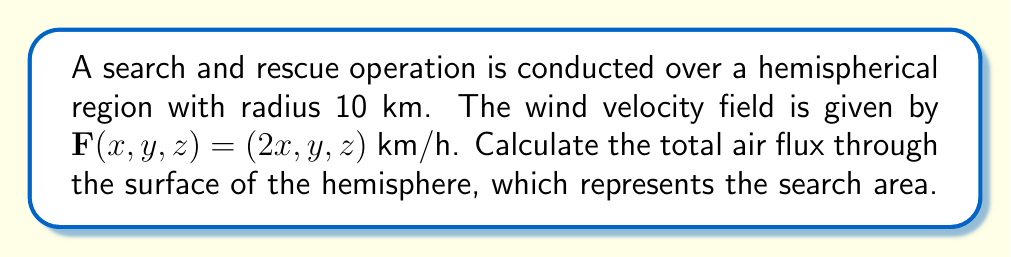Help me with this question. To solve this problem, we'll use the divergence theorem, which relates the flux of a vector field through a closed surface to the divergence of the field within the volume enclosed by the surface.

Step 1: Set up the divergence theorem
$$\iint_S \mathbf{F} \cdot \mathbf{n} \, dS = \iiint_V \nabla \cdot \mathbf{F} \, dV$$

Step 2: Calculate the divergence of $\mathbf{F}$
$$\nabla \cdot \mathbf{F} = \frac{\partial}{\partial x}(2x) + \frac{\partial}{\partial y}(y) + \frac{\partial}{\partial z}(z) = 2 + 1 + 1 = 4$$

Step 3: Set up the volume integral
The volume of a hemisphere is $\frac{2}{3}\pi r^3$, so our integral becomes:
$$\iiint_V \nabla \cdot \mathbf{F} \, dV = 4 \cdot \frac{2}{3}\pi r^3$$

Step 4: Substitute the given radius and calculate
$$4 \cdot \frac{2}{3}\pi (10)^3 = \frac{8000}{3}\pi \approx 8377.58 \text{ km}^3/\text{h}$$

This represents the total air flux through the surface of the hemisphere.
Answer: $\frac{8000}{3}\pi \approx 8377.58 \text{ km}^3/\text{h}$ 